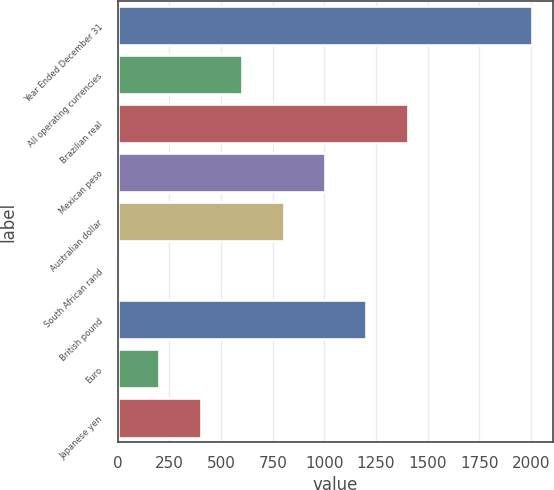<chart> <loc_0><loc_0><loc_500><loc_500><bar_chart><fcel>Year Ended December 31<fcel>All operating currencies<fcel>Brazilian real<fcel>Mexican peso<fcel>Australian dollar<fcel>South African rand<fcel>British pound<fcel>Euro<fcel>Japanese yen<nl><fcel>2005<fcel>602.2<fcel>1403.8<fcel>1003<fcel>802.6<fcel>1<fcel>1203.4<fcel>201.4<fcel>401.8<nl></chart> 